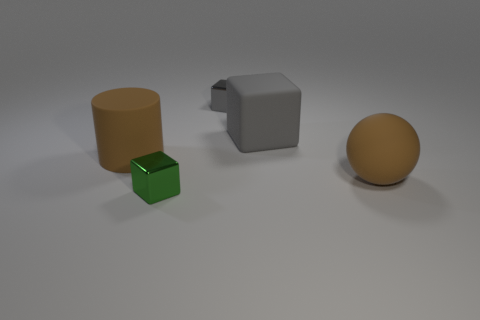The green metallic object that is the same shape as the gray metal object is what size?
Your answer should be compact. Small. Are there any small cubes in front of the tiny metallic object that is behind the brown ball?
Offer a very short reply. Yes. Is the ball the same color as the big rubber block?
Provide a succinct answer. No. Are there more big objects behind the small green block than gray rubber cubes that are to the left of the large brown rubber ball?
Your response must be concise. Yes. Does the rubber object that is on the left side of the tiny gray thing have the same size as the metallic thing behind the small green metallic block?
Provide a succinct answer. No. There is another cube that is the same color as the large block; what is its size?
Your answer should be very brief. Small. The large cylinder that is made of the same material as the brown sphere is what color?
Provide a short and direct response. Brown. Does the big cylinder have the same material as the small object left of the tiny gray block?
Give a very brief answer. No. What is the color of the big cube?
Ensure brevity in your answer.  Gray. What is the size of the thing that is made of the same material as the tiny green cube?
Offer a terse response. Small. 